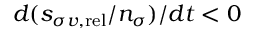Convert formula to latex. <formula><loc_0><loc_0><loc_500><loc_500>d ( s _ { \sigma v , r e l } / n _ { \sigma } ) / d t < 0</formula> 